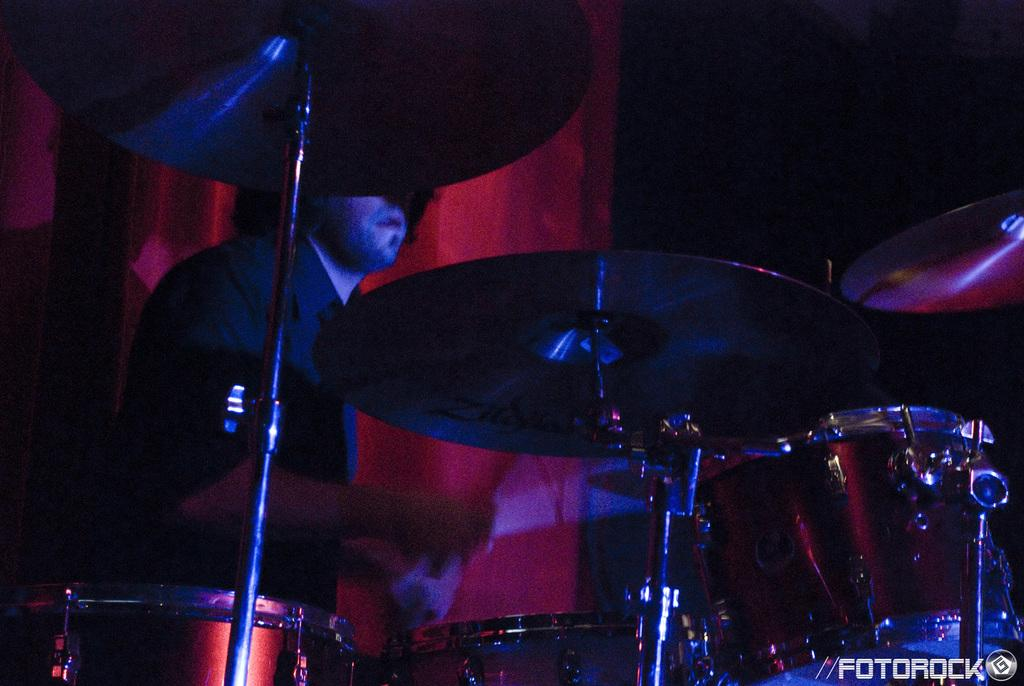What is the main subject of the image? The main subject of the image is a man. What is the man doing in the image? The man is playing an orchestra in the image. What is the man wearing in the image? The man is wearing a black shirt in the image. What can be seen in the background of the image? There is a red curtain in the background of the image. Can you tell me how many locks are visible on the man's instrument in the image? There are no locks visible on the man's instrument in the image. What type of record is being played by the man in the image? The image does not show any records being played; the man is playing an orchestra. 